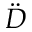<formula> <loc_0><loc_0><loc_500><loc_500>\ddot { D }</formula> 